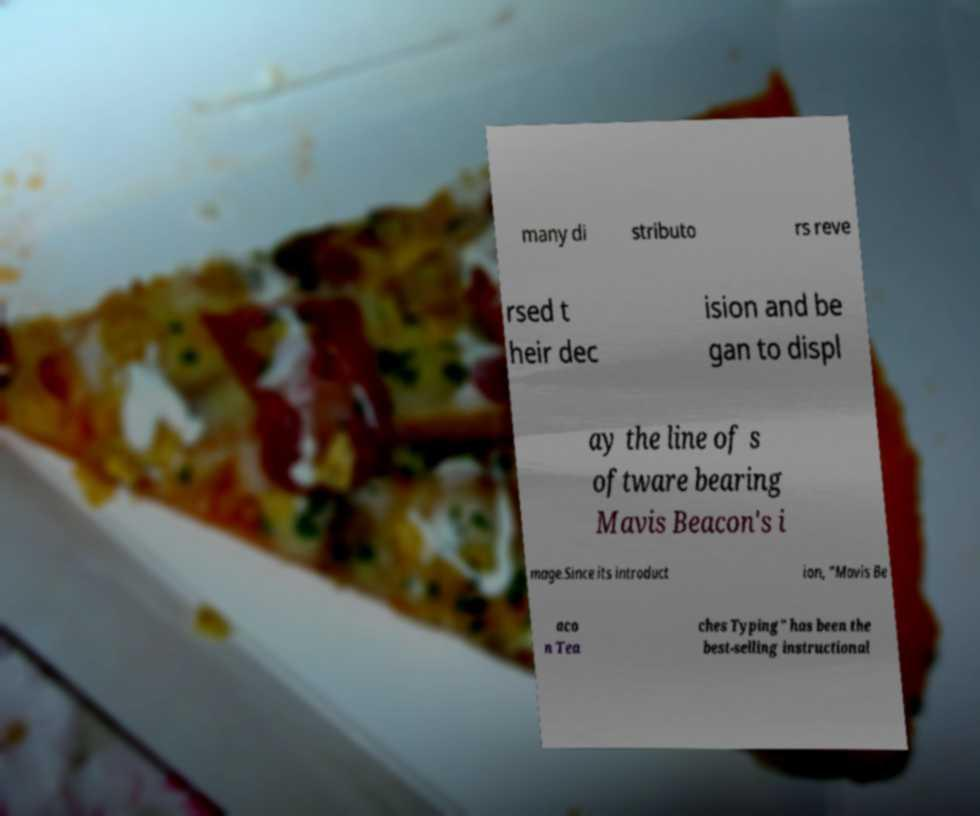Could you extract and type out the text from this image? many di stributo rs reve rsed t heir dec ision and be gan to displ ay the line of s oftware bearing Mavis Beacon's i mage.Since its introduct ion, "Mavis Be aco n Tea ches Typing" has been the best-selling instructional 